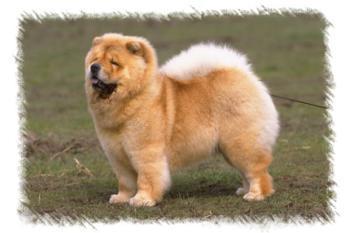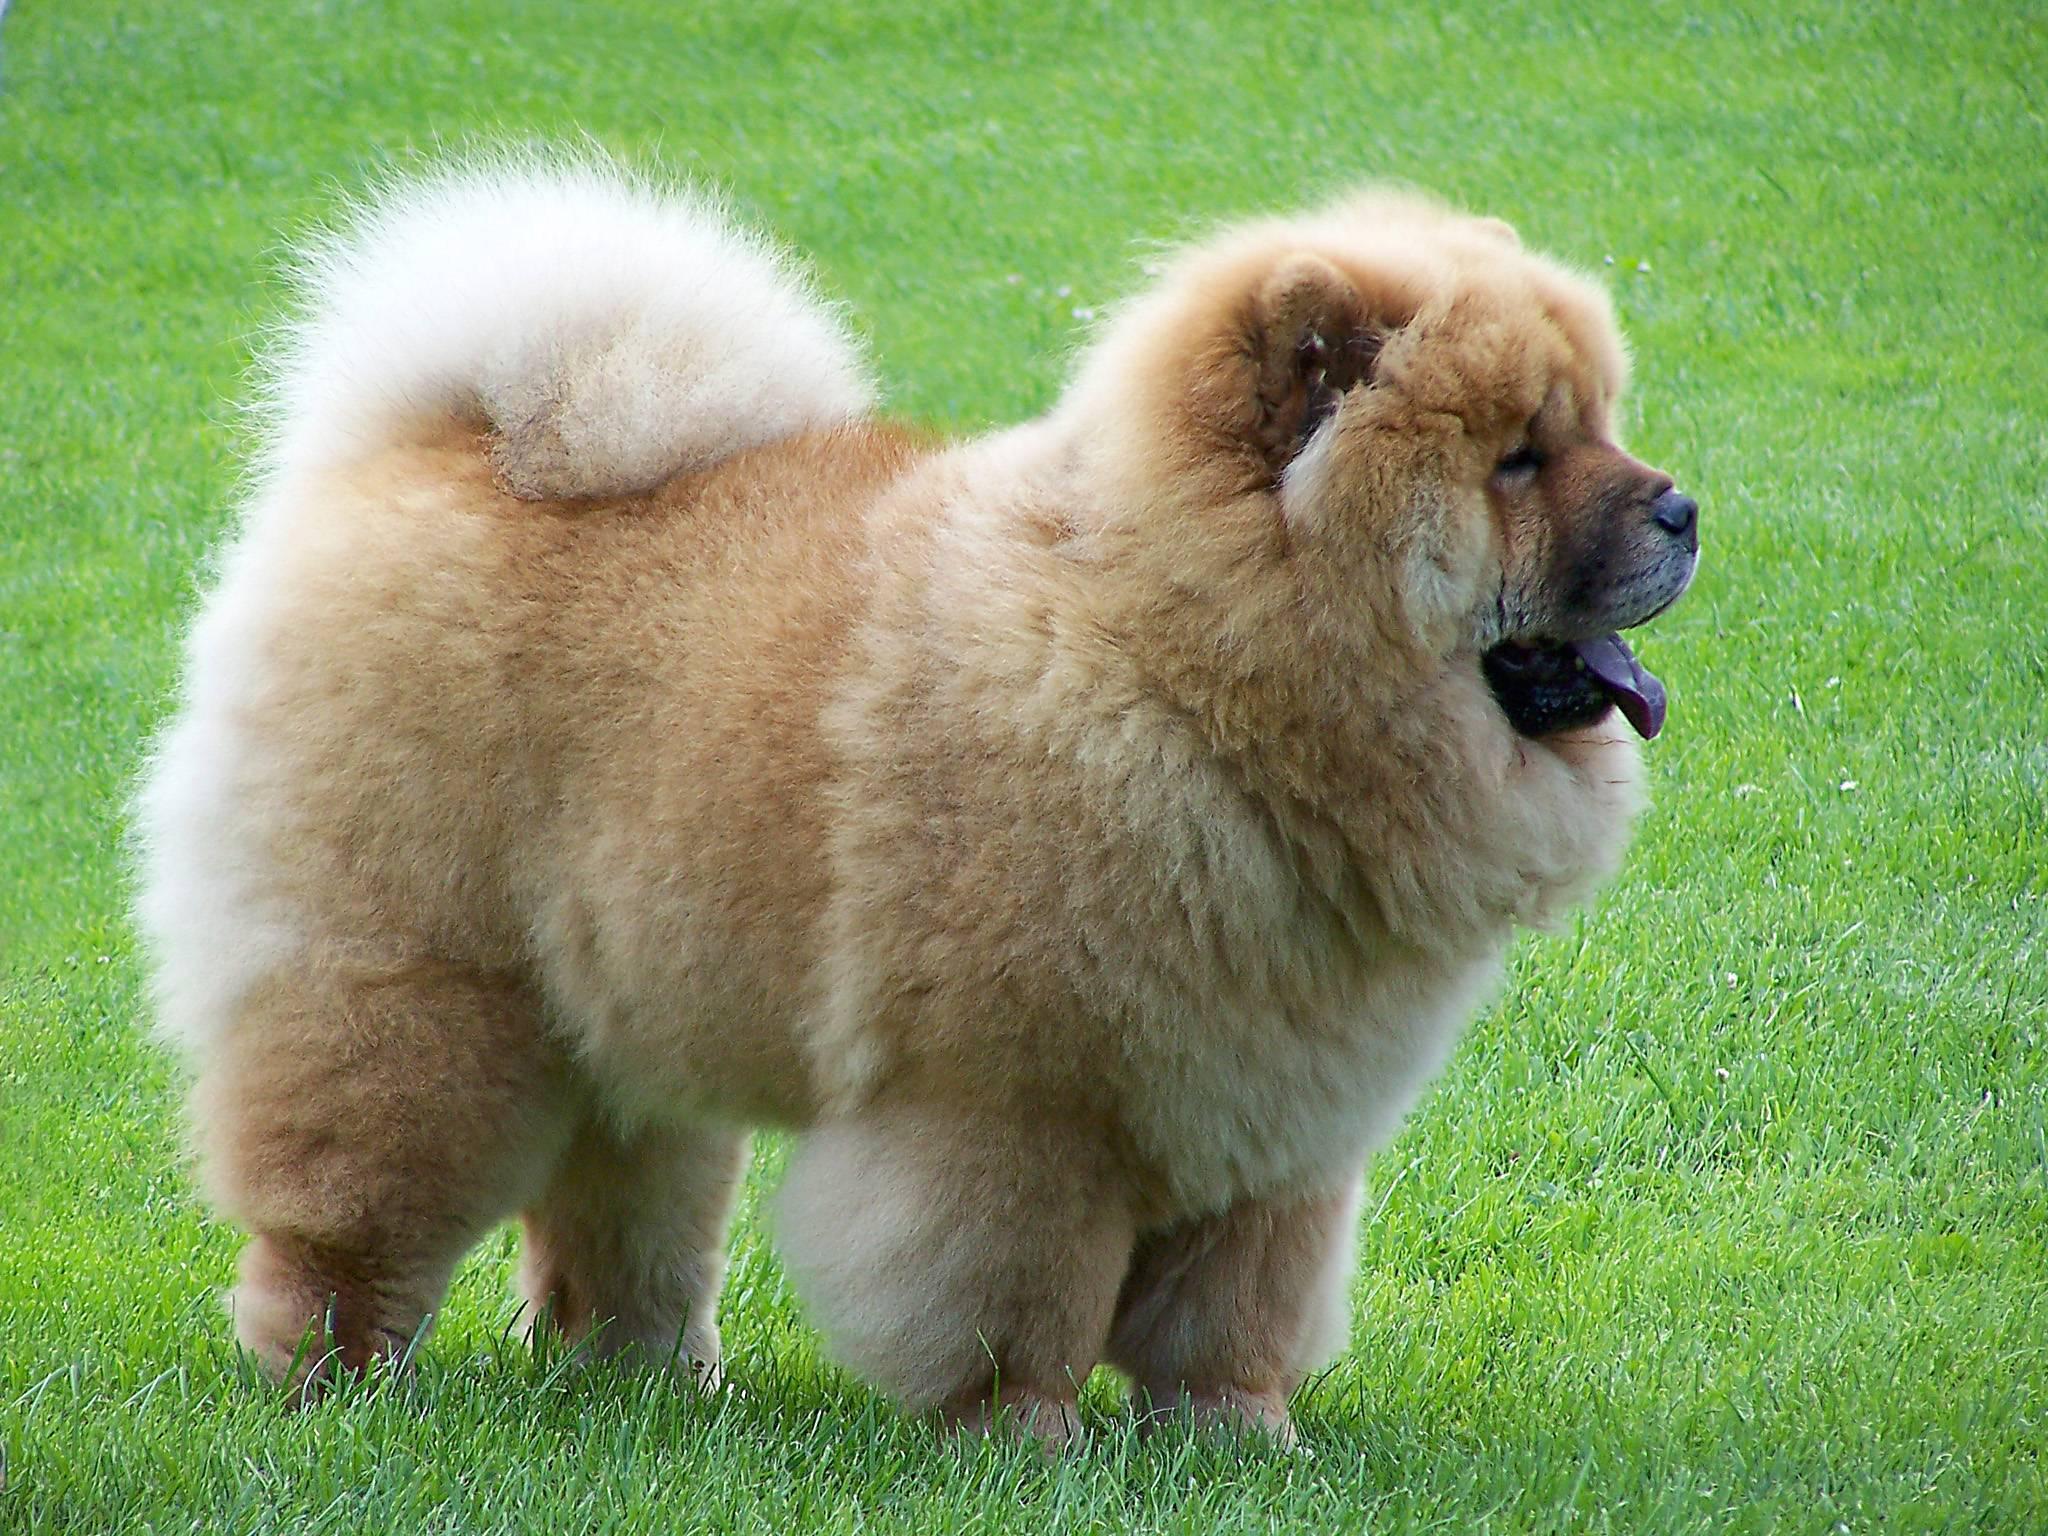The first image is the image on the left, the second image is the image on the right. For the images shown, is this caption "Both images feature young chow puppies, and the puppies on the left and right share similar poses with bodies turned in the same direction, but the puppy on the left is not on grass." true? Answer yes or no. No. The first image is the image on the left, the second image is the image on the right. Assess this claim about the two images: "Both of the images feature a dog standing on grass.". Correct or not? Answer yes or no. Yes. 